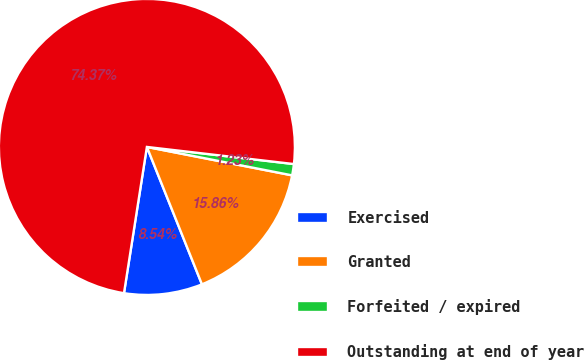Convert chart to OTSL. <chart><loc_0><loc_0><loc_500><loc_500><pie_chart><fcel>Exercised<fcel>Granted<fcel>Forfeited / expired<fcel>Outstanding at end of year<nl><fcel>8.54%<fcel>15.86%<fcel>1.23%<fcel>74.38%<nl></chart> 